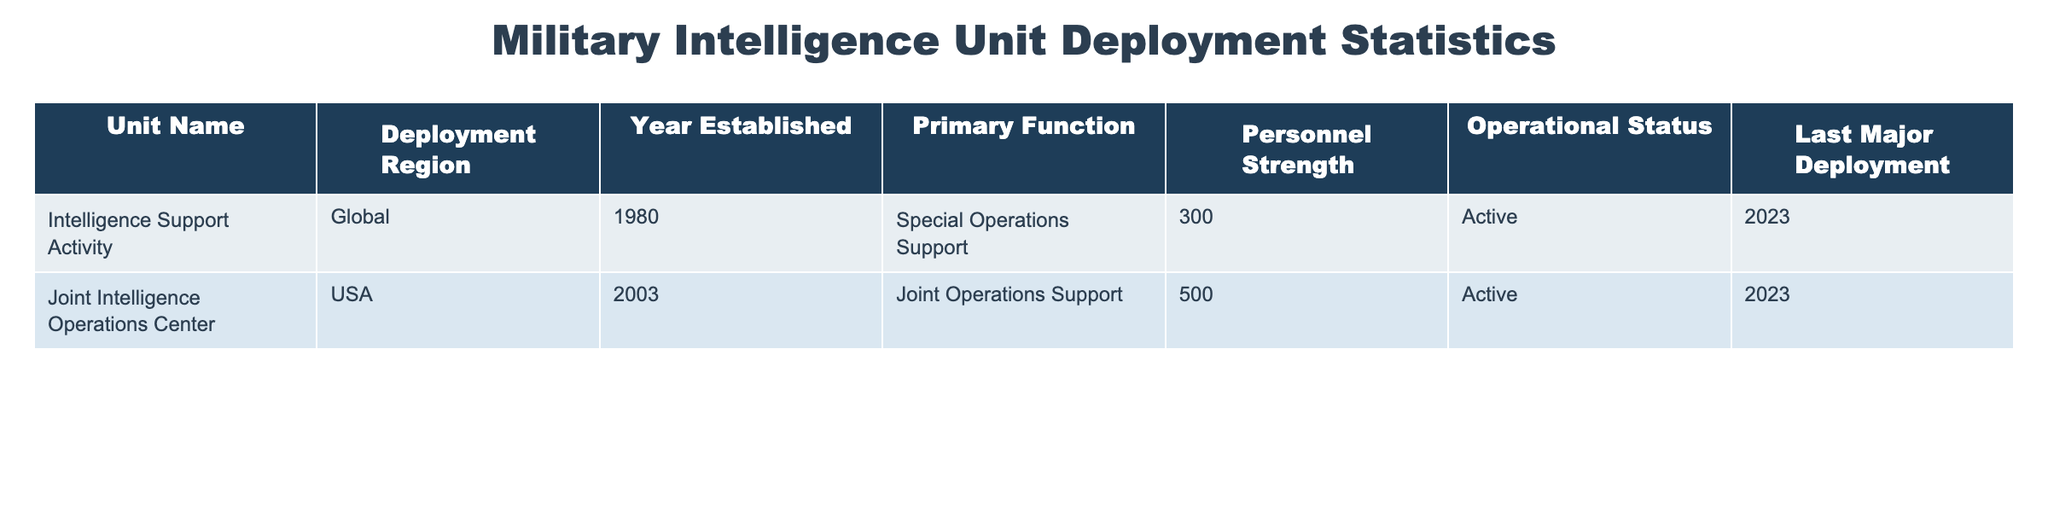What is the primary function of the Joint Intelligence Operations Center? The table shows that the primary function of the Joint Intelligence Operations Center is "Joint Operations Support." This information is directly stated in the "Primary Function" column for that unit.
Answer: Joint Operations Support How many personnel are assigned to the Intelligence Support Activity? Referring to the “Personnel Strength” column, the table indicates that the Intelligence Support Activity has 300 personnel assigned to it.
Answer: 300 Is the Joint Intelligence Operations Center currently active? The "Operational Status" column for the Joint Intelligence Operations Center indicates "Active," confirming that it is currently operational.
Answer: Yes Which unit has the largest personnel strength? By comparing the "Personnel Strength" column, the Joint Intelligence Operations Center has 500 personnel, which is higher than the 300 personnel of the Intelligence Support Activity, making it the largest.
Answer: Joint Intelligence Operations Center What is the last major deployment year for both units? The "Last Major Deployment" column indicates that both units were last deployed in 2023, thus showing they are currently active in operations.
Answer: 2023 What is the difference in personnel strength between the two units? The Intelligence Support Activity has 300 personnel and the Joint Intelligence Operations Center has 500 personnel. To find the difference, we subtract 300 from 500, giving us 200.
Answer: 200 Are both units established after the year 2000? The Intelligence Support Activity was established in 1980, while the Joint Intelligence Operations Center was established in 2003. Since one unit was established before 2000, the answer is no.
Answer: No If both units combine their personnel, what will be their total personnel strength? Adding together the personnel strengths, 300 (Intelligence Support Activity) + 500 (Joint Intelligence Operations Center) equals 800 personnel in total.
Answer: 800 Which unit was established first? Looking at the "Year Established" column, the Intelligence Support Activity was founded in 1980, and the Joint Intelligence Operations Center was established in 2003, thus the former was established first.
Answer: Intelligence Support Activity 